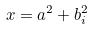Convert formula to latex. <formula><loc_0><loc_0><loc_500><loc_500>x = a ^ { 2 } + b _ { i } ^ { 2 }</formula> 